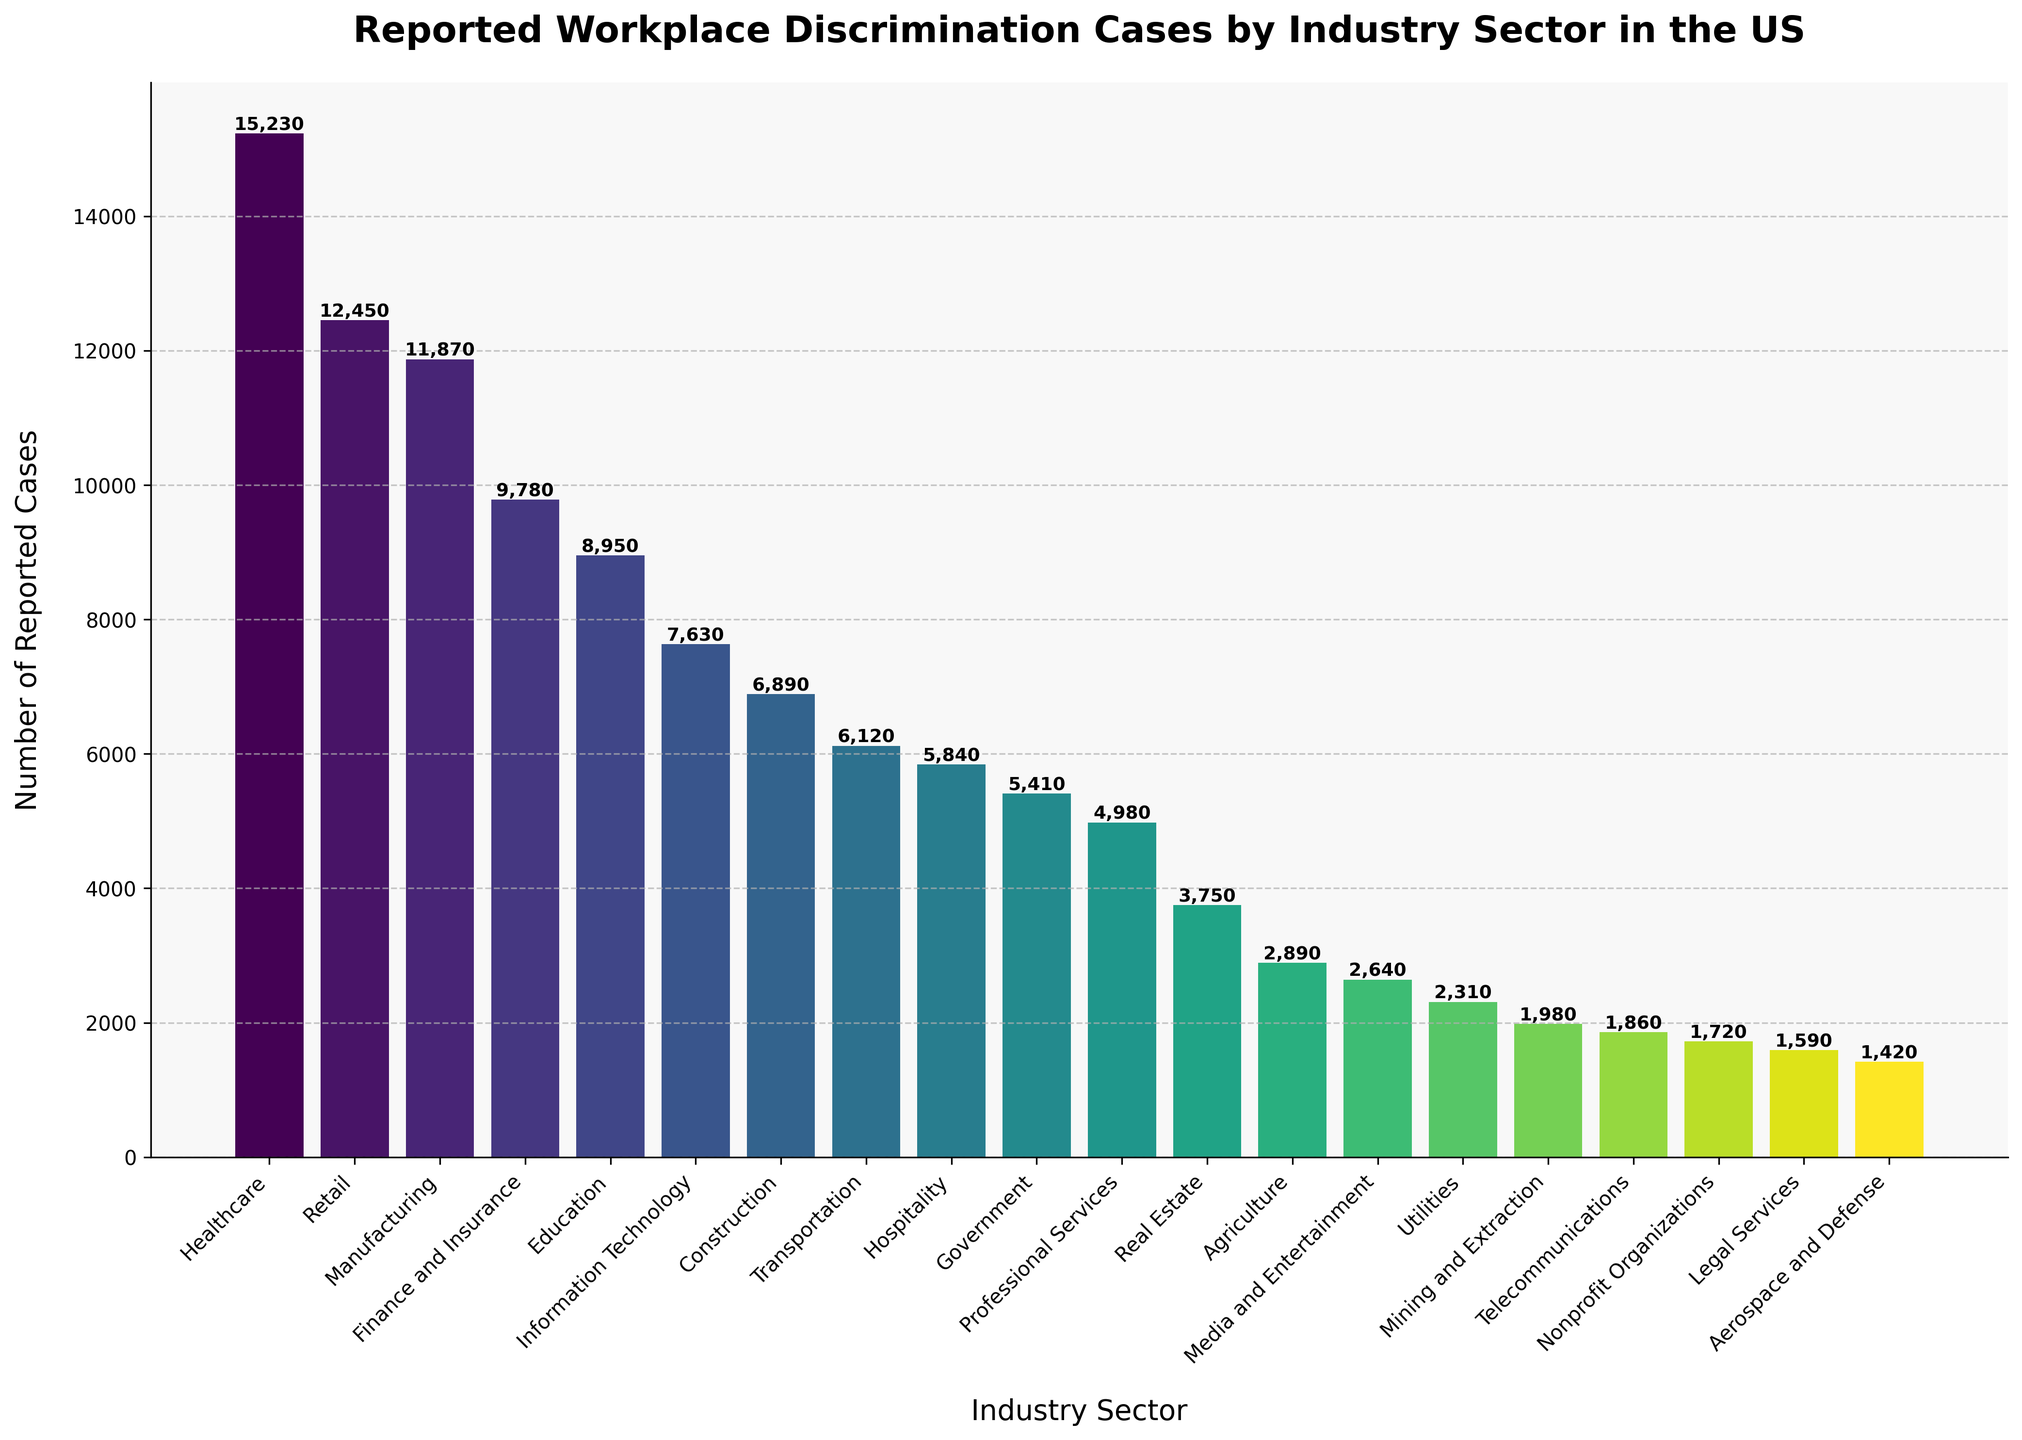Which industry sector reports the most workplace discrimination cases? Look at the top bar in the chart, which represents the industry with the highest number of reported cases. The label shows it's "Healthcare" with 15,230 cases.
Answer: Healthcare Which industry sector has reported fewer cases than Construction but more than Transportation? Find the bar for Construction, then look for the next bar below it and above Transportation. The bar between them is Information Technology with 7,630 cases.
Answer: Information Technology What is the difference in reported cases between the highest and lowest reporting sectors? The highest reporting sector is Healthcare with 15,230 cases. The lowest is Aerospace and Defense with 1,420 cases. Subtract the lowest from the highest: 15,230 - 1,420.
Answer: 13,810 Which sectors have less than 5,000 reported cases? Identify the bars with heights representing less than 5,000 cases. These sectors are Real Estate, Agriculture, Media and Entertainment, Utilities, Mining and Extraction, Telecommunications, Nonprofit Organizations, Legal Services, and Aerospace and Defense.
Answer: Real Estate, Agriculture, Media and Entertainment, Utilities, Mining and Extraction, Telecommunications, Nonprofit Organizations, Legal Services, Aerospace and Defense Among the top 5 sectors by reported cases, which one reports the third-highest number? List the top 5 sectors in descending order: Healthcare, Retail, Manufacturing, Finance and Insurance, Education. The third-highest is Manufacturing with 11,870 cases.
Answer: Manufacturing What is the combined total of reported cases for Education and Information Technology sectors? Add the reported cases for Education (8,950) and Information Technology (7,630): 8,950 + 7,630.
Answer: 16,580 Which sector reports exactly half the number of cases as the Finance and Insurance sector? Finance and Insurance reports 9,780 cases. Half of this is 4,890. Look at the bar closest to this number, which is Professional Services with 4,980 cases.
Answer: Professional Services Are there more reported cases in the Retail sector or the Government sector? Compare the heights of the bars for Retail (12,450) and Government (5,410). Retail is higher.
Answer: Retail Which industry group reports the least number of discrimination cases, and what is the count? Look at the shortest bar, which represents the lowest number of cases. It is Aerospace and Defense with 1,420 cases.
Answer: Aerospace and Defense What is the average number of reported cases among the top three sectors? The top three sectors are Healthcare (15,230), Retail (12,450), and Manufacturing (11,870). Calculate the average: (15,230 + 12,450 + 11,870) / 3.
Answer: 13,183.33 